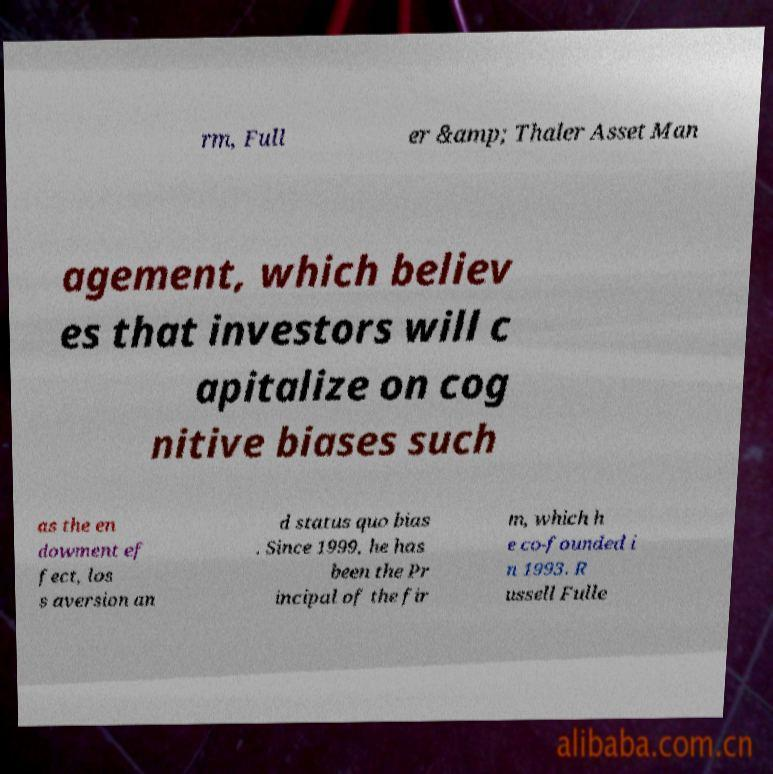Could you assist in decoding the text presented in this image and type it out clearly? rm, Full er &amp; Thaler Asset Man agement, which believ es that investors will c apitalize on cog nitive biases such as the en dowment ef fect, los s aversion an d status quo bias . Since 1999, he has been the Pr incipal of the fir m, which h e co-founded i n 1993. R ussell Fulle 